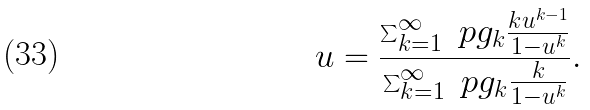Convert formula to latex. <formula><loc_0><loc_0><loc_500><loc_500>u = \frac { \sum _ { k = 1 } ^ { \infty } \ p g _ { k } \frac { k u ^ { k - 1 } } { 1 - u ^ { k } } } { \sum _ { k = 1 } ^ { \infty } \ p g _ { k } \frac { k } { 1 - u ^ { k } } } .</formula> 